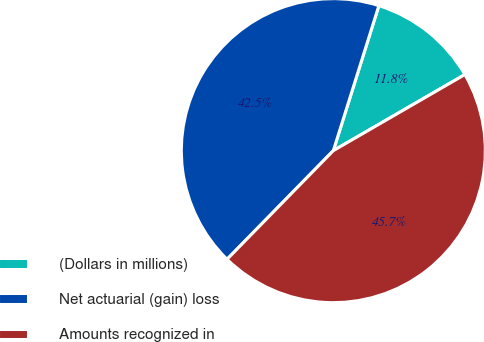Convert chart to OTSL. <chart><loc_0><loc_0><loc_500><loc_500><pie_chart><fcel>(Dollars in millions)<fcel>Net actuarial (gain) loss<fcel>Amounts recognized in<nl><fcel>11.81%<fcel>42.52%<fcel>45.67%<nl></chart> 